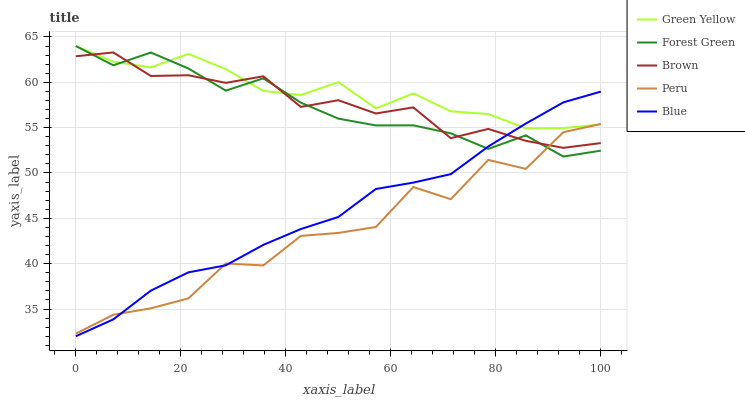Does Peru have the minimum area under the curve?
Answer yes or no. Yes. Does Green Yellow have the maximum area under the curve?
Answer yes or no. Yes. Does Brown have the minimum area under the curve?
Answer yes or no. No. Does Brown have the maximum area under the curve?
Answer yes or no. No. Is Blue the smoothest?
Answer yes or no. Yes. Is Peru the roughest?
Answer yes or no. Yes. Is Brown the smoothest?
Answer yes or no. No. Is Brown the roughest?
Answer yes or no. No. Does Brown have the lowest value?
Answer yes or no. No. Does Forest Green have the highest value?
Answer yes or no. Yes. Does Brown have the highest value?
Answer yes or no. No. Does Blue intersect Forest Green?
Answer yes or no. Yes. Is Blue less than Forest Green?
Answer yes or no. No. Is Blue greater than Forest Green?
Answer yes or no. No. 